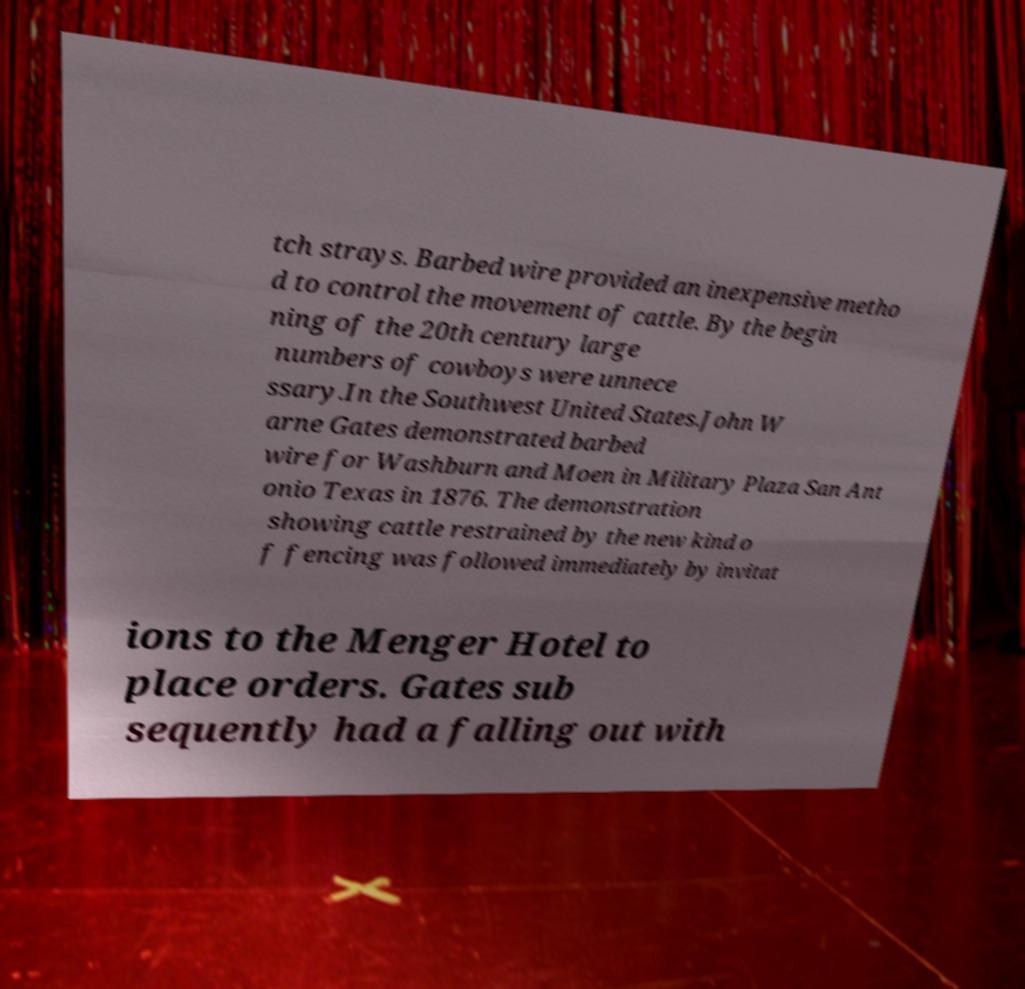Please identify and transcribe the text found in this image. tch strays. Barbed wire provided an inexpensive metho d to control the movement of cattle. By the begin ning of the 20th century large numbers of cowboys were unnece ssary.In the Southwest United States.John W arne Gates demonstrated barbed wire for Washburn and Moen in Military Plaza San Ant onio Texas in 1876. The demonstration showing cattle restrained by the new kind o f fencing was followed immediately by invitat ions to the Menger Hotel to place orders. Gates sub sequently had a falling out with 